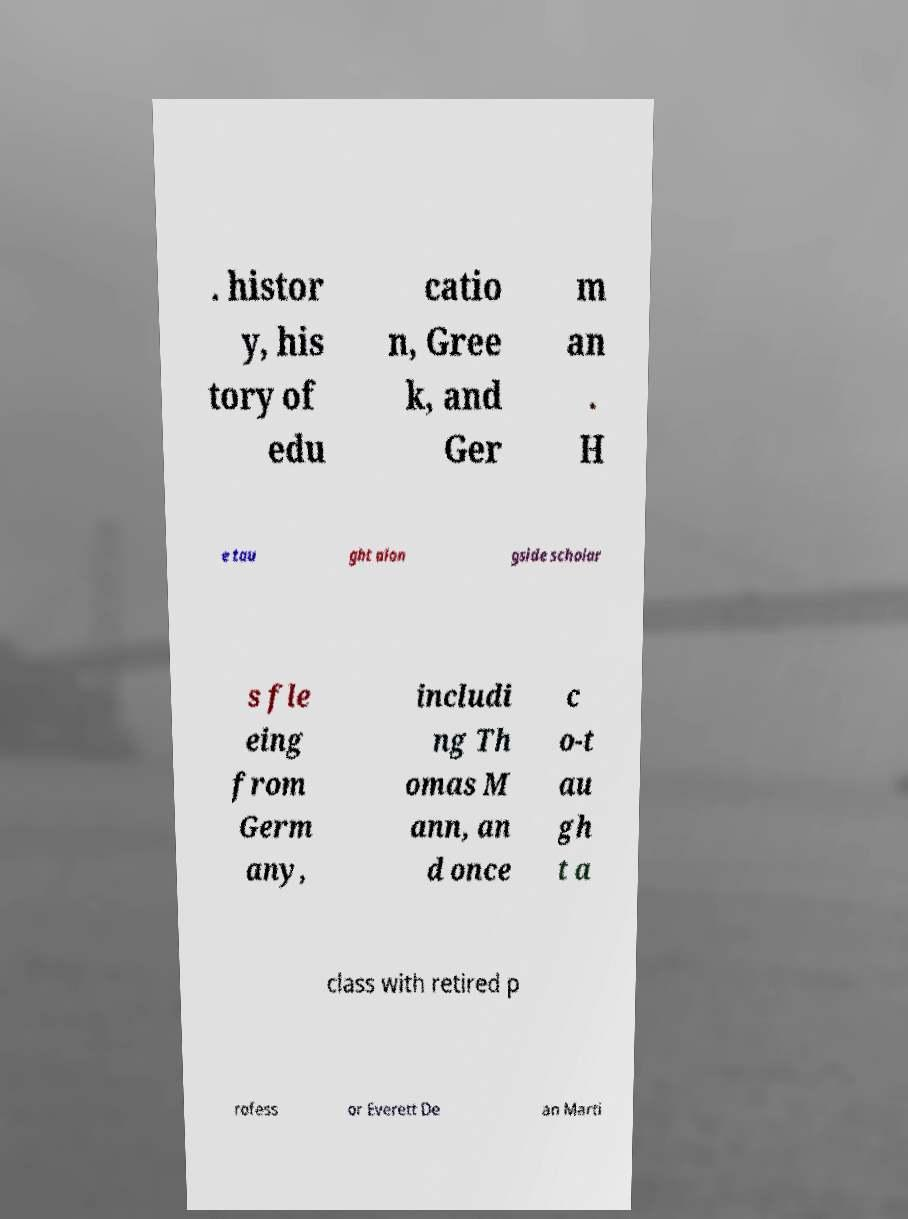I need the written content from this picture converted into text. Can you do that? . histor y, his tory of edu catio n, Gree k, and Ger m an . H e tau ght alon gside scholar s fle eing from Germ any, includi ng Th omas M ann, an d once c o-t au gh t a class with retired p rofess or Everett De an Marti 